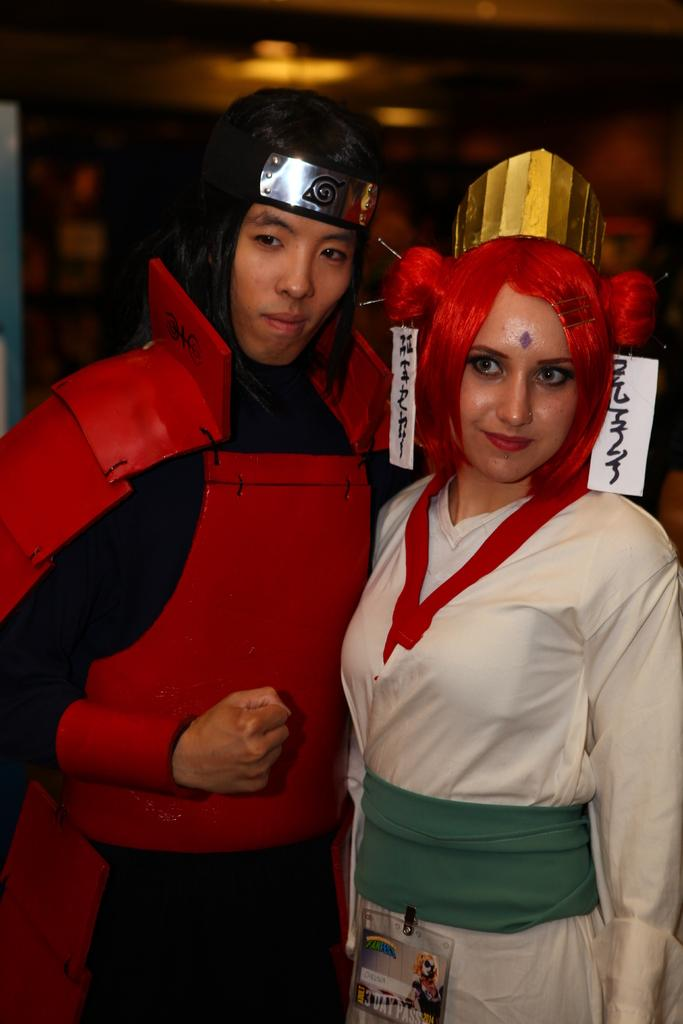What is the man in the image wearing? The man is wearing red armor and trousers. What is the woman in the image wearing? The woman is wearing a white dress. What can be seen in the background of the image? There is a wall in the background of the image. How many crows are perched on the man's armor in the image? There are no crows present in the image; the man is wearing red armor and trousers. 